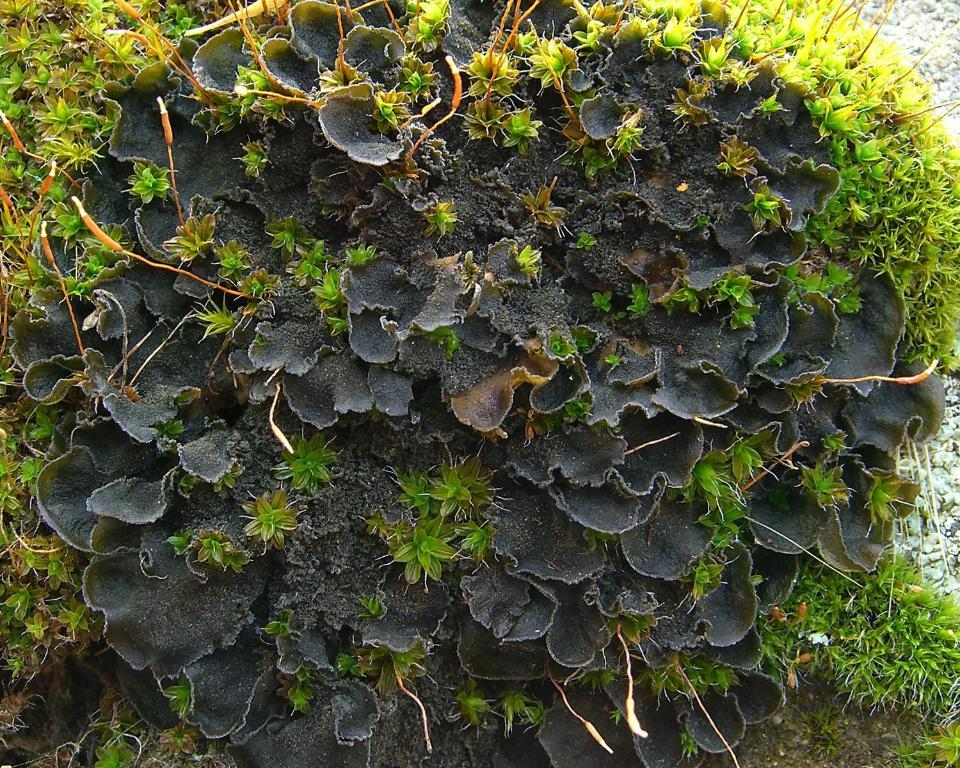What is the main subject in the center of the image? There is a plant in the center of the image. What type of vegetation can be seen at the bottom of the image? There is grass visible at the bottom of the image. What type of milk is being poured on the plant in the image? There is no milk present in the image; it only features a plant and grass. 